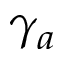Convert formula to latex. <formula><loc_0><loc_0><loc_500><loc_500>\gamma _ { a }</formula> 